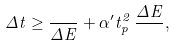Convert formula to latex. <formula><loc_0><loc_0><loc_500><loc_500>\Delta t \geq \frac { } { \Delta E } + \alpha ^ { \prime } t _ { p } ^ { 2 } \, \frac { \Delta E } { } ,</formula> 